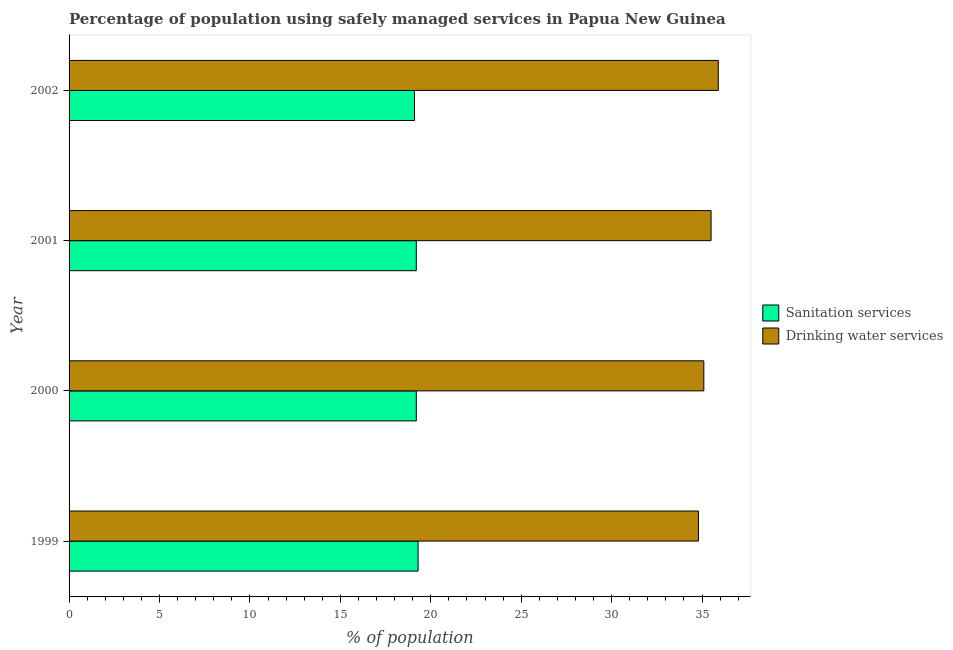How many bars are there on the 3rd tick from the bottom?
Ensure brevity in your answer.  2. What is the label of the 2nd group of bars from the top?
Give a very brief answer. 2001. What is the percentage of population who used sanitation services in 1999?
Your answer should be compact. 19.3. Across all years, what is the maximum percentage of population who used drinking water services?
Your response must be concise. 35.9. Across all years, what is the minimum percentage of population who used sanitation services?
Provide a succinct answer. 19.1. What is the total percentage of population who used drinking water services in the graph?
Offer a very short reply. 141.3. What is the difference between the percentage of population who used drinking water services in 1999 and the percentage of population who used sanitation services in 2000?
Make the answer very short. 15.6. What is the average percentage of population who used drinking water services per year?
Give a very brief answer. 35.33. What is the ratio of the percentage of population who used sanitation services in 2001 to that in 2002?
Provide a short and direct response. 1. Is the percentage of population who used sanitation services in 2000 less than that in 2001?
Provide a short and direct response. No. Is the difference between the percentage of population who used drinking water services in 1999 and 2000 greater than the difference between the percentage of population who used sanitation services in 1999 and 2000?
Offer a terse response. No. What is the difference between the highest and the second highest percentage of population who used drinking water services?
Offer a terse response. 0.4. What is the difference between the highest and the lowest percentage of population who used drinking water services?
Your response must be concise. 1.1. Is the sum of the percentage of population who used sanitation services in 1999 and 2002 greater than the maximum percentage of population who used drinking water services across all years?
Your answer should be very brief. Yes. What does the 1st bar from the top in 2000 represents?
Ensure brevity in your answer.  Drinking water services. What does the 2nd bar from the bottom in 1999 represents?
Provide a short and direct response. Drinking water services. How many bars are there?
Offer a terse response. 8. Are all the bars in the graph horizontal?
Your answer should be compact. Yes. How many years are there in the graph?
Keep it short and to the point. 4. Does the graph contain grids?
Your answer should be compact. No. Where does the legend appear in the graph?
Offer a terse response. Center right. How are the legend labels stacked?
Keep it short and to the point. Vertical. What is the title of the graph?
Provide a short and direct response. Percentage of population using safely managed services in Papua New Guinea. What is the label or title of the X-axis?
Keep it short and to the point. % of population. What is the % of population of Sanitation services in 1999?
Offer a very short reply. 19.3. What is the % of population of Drinking water services in 1999?
Your response must be concise. 34.8. What is the % of population in Sanitation services in 2000?
Your response must be concise. 19.2. What is the % of population in Drinking water services in 2000?
Provide a succinct answer. 35.1. What is the % of population of Drinking water services in 2001?
Your answer should be compact. 35.5. What is the % of population of Sanitation services in 2002?
Your answer should be very brief. 19.1. What is the % of population in Drinking water services in 2002?
Your response must be concise. 35.9. Across all years, what is the maximum % of population of Sanitation services?
Provide a succinct answer. 19.3. Across all years, what is the maximum % of population of Drinking water services?
Your response must be concise. 35.9. Across all years, what is the minimum % of population in Sanitation services?
Offer a terse response. 19.1. Across all years, what is the minimum % of population in Drinking water services?
Give a very brief answer. 34.8. What is the total % of population in Sanitation services in the graph?
Your response must be concise. 76.8. What is the total % of population in Drinking water services in the graph?
Offer a terse response. 141.3. What is the difference between the % of population in Sanitation services in 1999 and that in 2000?
Ensure brevity in your answer.  0.1. What is the difference between the % of population in Sanitation services in 1999 and that in 2001?
Provide a succinct answer. 0.1. What is the difference between the % of population in Drinking water services in 1999 and that in 2001?
Offer a very short reply. -0.7. What is the difference between the % of population in Drinking water services in 1999 and that in 2002?
Your answer should be very brief. -1.1. What is the difference between the % of population of Drinking water services in 2000 and that in 2001?
Keep it short and to the point. -0.4. What is the difference between the % of population in Sanitation services in 2000 and that in 2002?
Ensure brevity in your answer.  0.1. What is the difference between the % of population in Drinking water services in 2000 and that in 2002?
Provide a short and direct response. -0.8. What is the difference between the % of population in Sanitation services in 1999 and the % of population in Drinking water services in 2000?
Ensure brevity in your answer.  -15.8. What is the difference between the % of population in Sanitation services in 1999 and the % of population in Drinking water services in 2001?
Give a very brief answer. -16.2. What is the difference between the % of population of Sanitation services in 1999 and the % of population of Drinking water services in 2002?
Offer a terse response. -16.6. What is the difference between the % of population in Sanitation services in 2000 and the % of population in Drinking water services in 2001?
Give a very brief answer. -16.3. What is the difference between the % of population of Sanitation services in 2000 and the % of population of Drinking water services in 2002?
Offer a very short reply. -16.7. What is the difference between the % of population of Sanitation services in 2001 and the % of population of Drinking water services in 2002?
Ensure brevity in your answer.  -16.7. What is the average % of population in Sanitation services per year?
Offer a terse response. 19.2. What is the average % of population in Drinking water services per year?
Make the answer very short. 35.33. In the year 1999, what is the difference between the % of population in Sanitation services and % of population in Drinking water services?
Your answer should be compact. -15.5. In the year 2000, what is the difference between the % of population of Sanitation services and % of population of Drinking water services?
Provide a short and direct response. -15.9. In the year 2001, what is the difference between the % of population of Sanitation services and % of population of Drinking water services?
Offer a terse response. -16.3. In the year 2002, what is the difference between the % of population of Sanitation services and % of population of Drinking water services?
Offer a terse response. -16.8. What is the ratio of the % of population of Drinking water services in 1999 to that in 2000?
Give a very brief answer. 0.99. What is the ratio of the % of population in Drinking water services in 1999 to that in 2001?
Give a very brief answer. 0.98. What is the ratio of the % of population in Sanitation services in 1999 to that in 2002?
Provide a succinct answer. 1.01. What is the ratio of the % of population in Drinking water services in 1999 to that in 2002?
Give a very brief answer. 0.97. What is the ratio of the % of population in Sanitation services in 2000 to that in 2001?
Give a very brief answer. 1. What is the ratio of the % of population of Drinking water services in 2000 to that in 2001?
Your response must be concise. 0.99. What is the ratio of the % of population in Drinking water services in 2000 to that in 2002?
Offer a very short reply. 0.98. What is the ratio of the % of population in Sanitation services in 2001 to that in 2002?
Your answer should be very brief. 1.01. What is the ratio of the % of population of Drinking water services in 2001 to that in 2002?
Your answer should be compact. 0.99. What is the difference between the highest and the second highest % of population of Sanitation services?
Provide a succinct answer. 0.1. What is the difference between the highest and the second highest % of population in Drinking water services?
Your answer should be very brief. 0.4. What is the difference between the highest and the lowest % of population in Drinking water services?
Keep it short and to the point. 1.1. 